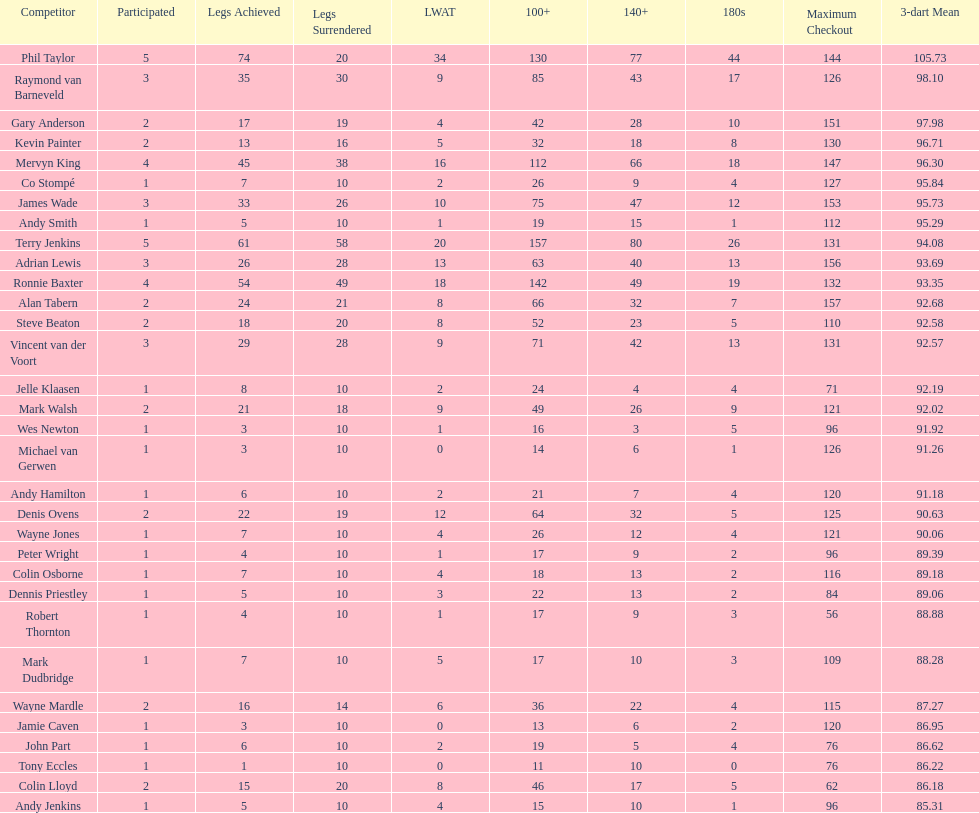Who won the highest number of legs in the 2009 world matchplay? Phil Taylor. 